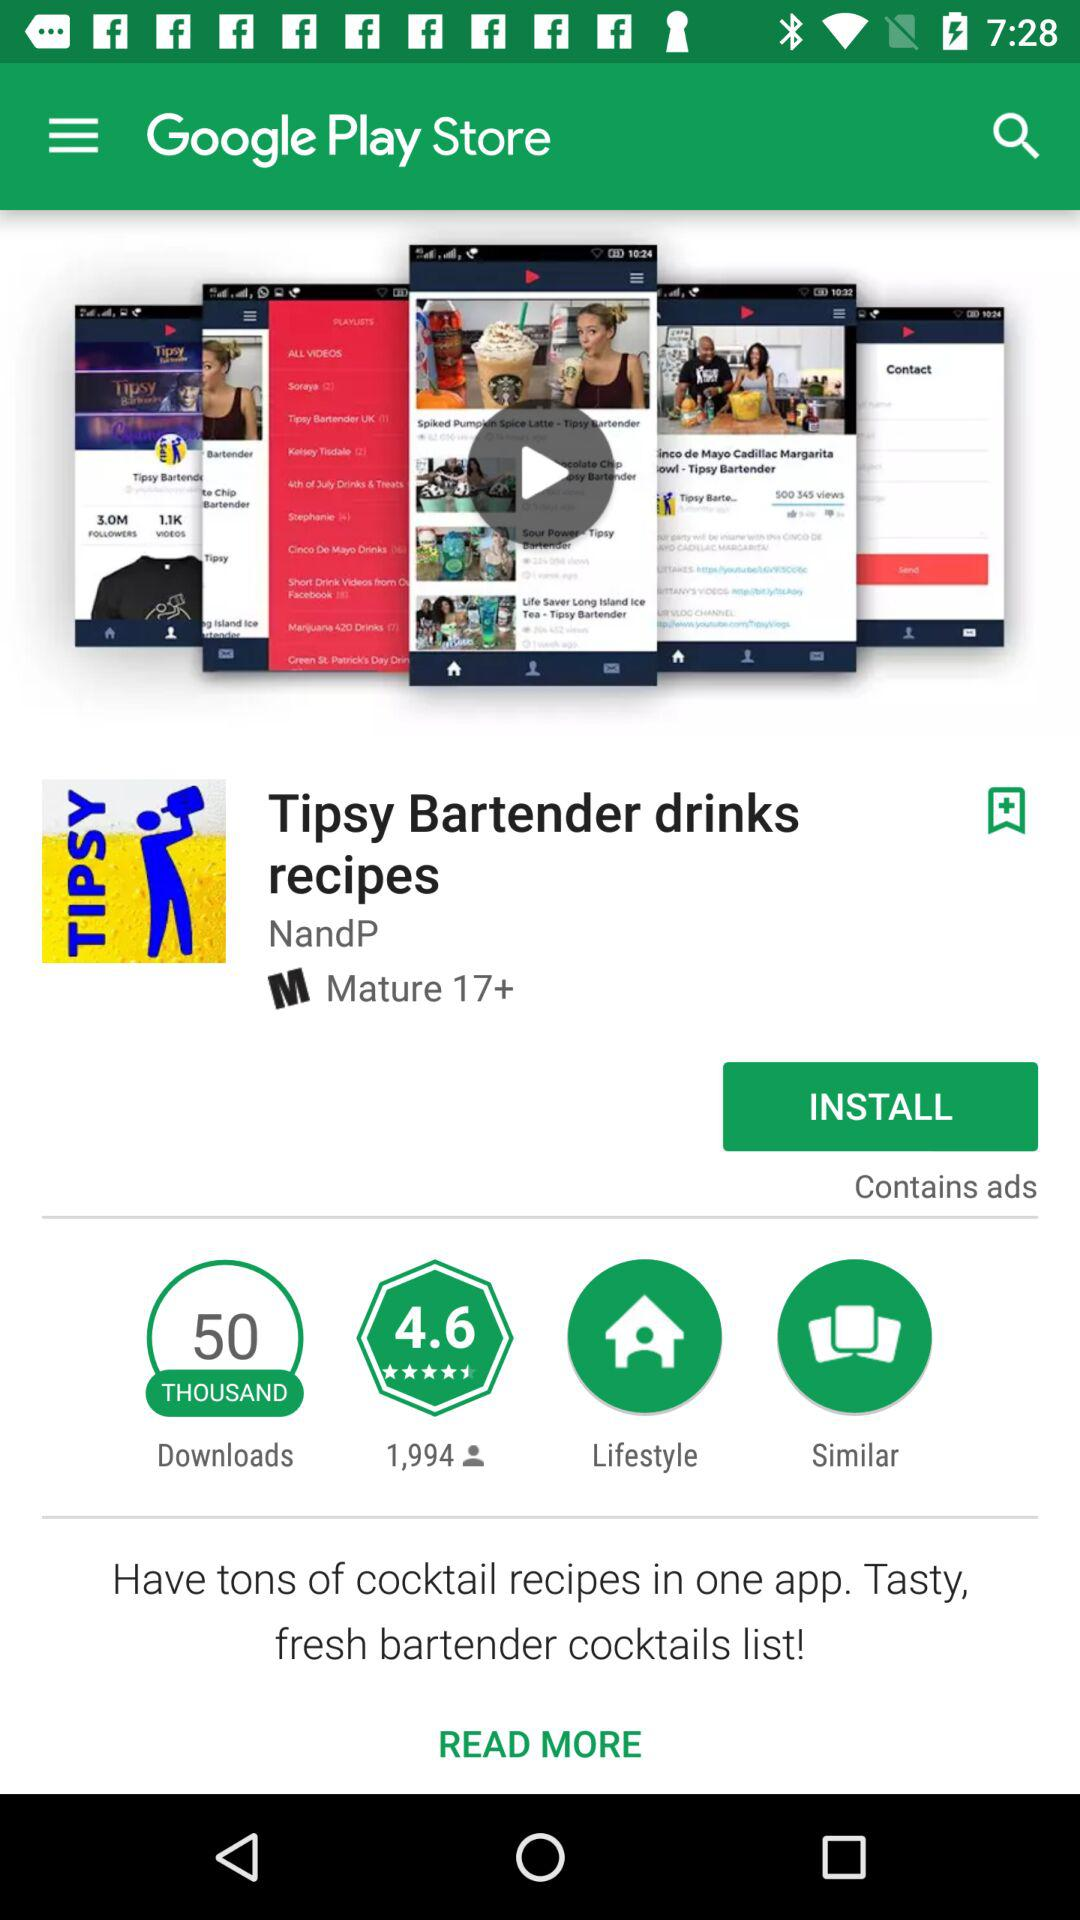What is the star rating for the "Tipsy Bartender drinks recipes" application? The star rating is 4.6. 